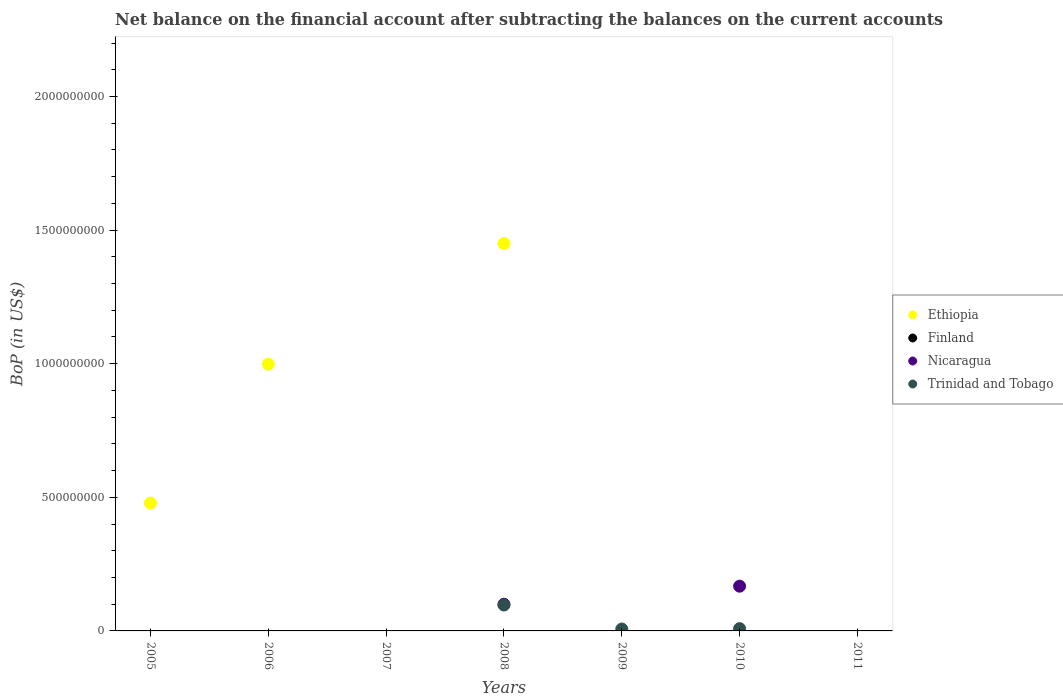How many different coloured dotlines are there?
Provide a succinct answer. 3. What is the Balance of Payments in Trinidad and Tobago in 2008?
Provide a succinct answer. 9.70e+07. Across all years, what is the maximum Balance of Payments in Trinidad and Tobago?
Ensure brevity in your answer.  9.70e+07. Across all years, what is the minimum Balance of Payments in Ethiopia?
Ensure brevity in your answer.  0. What is the total Balance of Payments in Finland in the graph?
Offer a very short reply. 0. What is the difference between the Balance of Payments in Trinidad and Tobago in 2008 and that in 2010?
Make the answer very short. 8.84e+07. What is the average Balance of Payments in Nicaragua per year?
Your response must be concise. 3.82e+07. In the year 2008, what is the difference between the Balance of Payments in Ethiopia and Balance of Payments in Trinidad and Tobago?
Give a very brief answer. 1.35e+09. What is the difference between the highest and the lowest Balance of Payments in Trinidad and Tobago?
Give a very brief answer. 9.70e+07. In how many years, is the Balance of Payments in Nicaragua greater than the average Balance of Payments in Nicaragua taken over all years?
Your response must be concise. 2. Is the Balance of Payments in Trinidad and Tobago strictly greater than the Balance of Payments in Finland over the years?
Offer a terse response. Yes. Is the Balance of Payments in Finland strictly less than the Balance of Payments in Ethiopia over the years?
Provide a succinct answer. No. How many dotlines are there?
Your response must be concise. 3. How many years are there in the graph?
Your answer should be very brief. 7. Are the values on the major ticks of Y-axis written in scientific E-notation?
Your response must be concise. No. Does the graph contain grids?
Ensure brevity in your answer.  No. How many legend labels are there?
Provide a short and direct response. 4. How are the legend labels stacked?
Your answer should be very brief. Vertical. What is the title of the graph?
Your response must be concise. Net balance on the financial account after subtracting the balances on the current accounts. What is the label or title of the Y-axis?
Offer a terse response. BoP (in US$). What is the BoP (in US$) of Ethiopia in 2005?
Your answer should be compact. 4.78e+08. What is the BoP (in US$) of Finland in 2005?
Ensure brevity in your answer.  0. What is the BoP (in US$) of Ethiopia in 2006?
Keep it short and to the point. 9.98e+08. What is the BoP (in US$) in Finland in 2006?
Make the answer very short. 0. What is the BoP (in US$) of Trinidad and Tobago in 2006?
Provide a succinct answer. 0. What is the BoP (in US$) of Nicaragua in 2007?
Ensure brevity in your answer.  0. What is the BoP (in US$) in Trinidad and Tobago in 2007?
Offer a terse response. 0. What is the BoP (in US$) in Ethiopia in 2008?
Your answer should be very brief. 1.45e+09. What is the BoP (in US$) of Finland in 2008?
Make the answer very short. 0. What is the BoP (in US$) of Nicaragua in 2008?
Give a very brief answer. 9.99e+07. What is the BoP (in US$) of Trinidad and Tobago in 2008?
Provide a short and direct response. 9.70e+07. What is the BoP (in US$) of Ethiopia in 2009?
Make the answer very short. 0. What is the BoP (in US$) of Finland in 2009?
Ensure brevity in your answer.  0. What is the BoP (in US$) in Nicaragua in 2009?
Provide a short and direct response. 0. What is the BoP (in US$) in Trinidad and Tobago in 2009?
Offer a terse response. 7.12e+06. What is the BoP (in US$) in Finland in 2010?
Make the answer very short. 0. What is the BoP (in US$) in Nicaragua in 2010?
Your response must be concise. 1.67e+08. What is the BoP (in US$) in Trinidad and Tobago in 2010?
Provide a succinct answer. 8.57e+06. What is the BoP (in US$) of Ethiopia in 2011?
Your answer should be compact. 0. Across all years, what is the maximum BoP (in US$) in Ethiopia?
Ensure brevity in your answer.  1.45e+09. Across all years, what is the maximum BoP (in US$) of Nicaragua?
Your answer should be very brief. 1.67e+08. Across all years, what is the maximum BoP (in US$) in Trinidad and Tobago?
Offer a very short reply. 9.70e+07. Across all years, what is the minimum BoP (in US$) of Nicaragua?
Give a very brief answer. 0. What is the total BoP (in US$) of Ethiopia in the graph?
Offer a very short reply. 2.93e+09. What is the total BoP (in US$) in Finland in the graph?
Keep it short and to the point. 0. What is the total BoP (in US$) in Nicaragua in the graph?
Your answer should be compact. 2.67e+08. What is the total BoP (in US$) in Trinidad and Tobago in the graph?
Provide a short and direct response. 1.13e+08. What is the difference between the BoP (in US$) in Ethiopia in 2005 and that in 2006?
Offer a very short reply. -5.20e+08. What is the difference between the BoP (in US$) of Ethiopia in 2005 and that in 2008?
Provide a short and direct response. -9.72e+08. What is the difference between the BoP (in US$) of Ethiopia in 2006 and that in 2008?
Make the answer very short. -4.52e+08. What is the difference between the BoP (in US$) of Trinidad and Tobago in 2008 and that in 2009?
Provide a short and direct response. 8.98e+07. What is the difference between the BoP (in US$) in Nicaragua in 2008 and that in 2010?
Give a very brief answer. -6.75e+07. What is the difference between the BoP (in US$) in Trinidad and Tobago in 2008 and that in 2010?
Give a very brief answer. 8.84e+07. What is the difference between the BoP (in US$) of Trinidad and Tobago in 2009 and that in 2010?
Ensure brevity in your answer.  -1.45e+06. What is the difference between the BoP (in US$) in Ethiopia in 2005 and the BoP (in US$) in Nicaragua in 2008?
Provide a short and direct response. 3.78e+08. What is the difference between the BoP (in US$) in Ethiopia in 2005 and the BoP (in US$) in Trinidad and Tobago in 2008?
Keep it short and to the point. 3.81e+08. What is the difference between the BoP (in US$) in Ethiopia in 2005 and the BoP (in US$) in Trinidad and Tobago in 2009?
Provide a succinct answer. 4.71e+08. What is the difference between the BoP (in US$) of Ethiopia in 2005 and the BoP (in US$) of Nicaragua in 2010?
Provide a succinct answer. 3.11e+08. What is the difference between the BoP (in US$) of Ethiopia in 2005 and the BoP (in US$) of Trinidad and Tobago in 2010?
Provide a short and direct response. 4.70e+08. What is the difference between the BoP (in US$) in Ethiopia in 2006 and the BoP (in US$) in Nicaragua in 2008?
Keep it short and to the point. 8.98e+08. What is the difference between the BoP (in US$) of Ethiopia in 2006 and the BoP (in US$) of Trinidad and Tobago in 2008?
Provide a short and direct response. 9.01e+08. What is the difference between the BoP (in US$) of Ethiopia in 2006 and the BoP (in US$) of Trinidad and Tobago in 2009?
Give a very brief answer. 9.91e+08. What is the difference between the BoP (in US$) in Ethiopia in 2006 and the BoP (in US$) in Nicaragua in 2010?
Offer a very short reply. 8.31e+08. What is the difference between the BoP (in US$) of Ethiopia in 2006 and the BoP (in US$) of Trinidad and Tobago in 2010?
Offer a very short reply. 9.90e+08. What is the difference between the BoP (in US$) in Ethiopia in 2008 and the BoP (in US$) in Trinidad and Tobago in 2009?
Your response must be concise. 1.44e+09. What is the difference between the BoP (in US$) of Nicaragua in 2008 and the BoP (in US$) of Trinidad and Tobago in 2009?
Provide a short and direct response. 9.28e+07. What is the difference between the BoP (in US$) in Ethiopia in 2008 and the BoP (in US$) in Nicaragua in 2010?
Provide a succinct answer. 1.28e+09. What is the difference between the BoP (in US$) in Ethiopia in 2008 and the BoP (in US$) in Trinidad and Tobago in 2010?
Provide a succinct answer. 1.44e+09. What is the difference between the BoP (in US$) of Nicaragua in 2008 and the BoP (in US$) of Trinidad and Tobago in 2010?
Make the answer very short. 9.13e+07. What is the average BoP (in US$) of Ethiopia per year?
Give a very brief answer. 4.18e+08. What is the average BoP (in US$) of Nicaragua per year?
Your answer should be very brief. 3.82e+07. What is the average BoP (in US$) of Trinidad and Tobago per year?
Your answer should be compact. 1.61e+07. In the year 2008, what is the difference between the BoP (in US$) in Ethiopia and BoP (in US$) in Nicaragua?
Keep it short and to the point. 1.35e+09. In the year 2008, what is the difference between the BoP (in US$) of Ethiopia and BoP (in US$) of Trinidad and Tobago?
Offer a very short reply. 1.35e+09. In the year 2008, what is the difference between the BoP (in US$) of Nicaragua and BoP (in US$) of Trinidad and Tobago?
Your answer should be compact. 2.93e+06. In the year 2010, what is the difference between the BoP (in US$) in Nicaragua and BoP (in US$) in Trinidad and Tobago?
Your answer should be very brief. 1.59e+08. What is the ratio of the BoP (in US$) of Ethiopia in 2005 to that in 2006?
Give a very brief answer. 0.48. What is the ratio of the BoP (in US$) in Ethiopia in 2005 to that in 2008?
Offer a terse response. 0.33. What is the ratio of the BoP (in US$) in Ethiopia in 2006 to that in 2008?
Give a very brief answer. 0.69. What is the ratio of the BoP (in US$) in Trinidad and Tobago in 2008 to that in 2009?
Make the answer very short. 13.61. What is the ratio of the BoP (in US$) in Nicaragua in 2008 to that in 2010?
Your response must be concise. 0.6. What is the ratio of the BoP (in US$) of Trinidad and Tobago in 2008 to that in 2010?
Offer a very short reply. 11.31. What is the ratio of the BoP (in US$) of Trinidad and Tobago in 2009 to that in 2010?
Offer a terse response. 0.83. What is the difference between the highest and the second highest BoP (in US$) in Ethiopia?
Your answer should be very brief. 4.52e+08. What is the difference between the highest and the second highest BoP (in US$) in Trinidad and Tobago?
Make the answer very short. 8.84e+07. What is the difference between the highest and the lowest BoP (in US$) in Ethiopia?
Keep it short and to the point. 1.45e+09. What is the difference between the highest and the lowest BoP (in US$) of Nicaragua?
Offer a very short reply. 1.67e+08. What is the difference between the highest and the lowest BoP (in US$) of Trinidad and Tobago?
Your answer should be compact. 9.70e+07. 